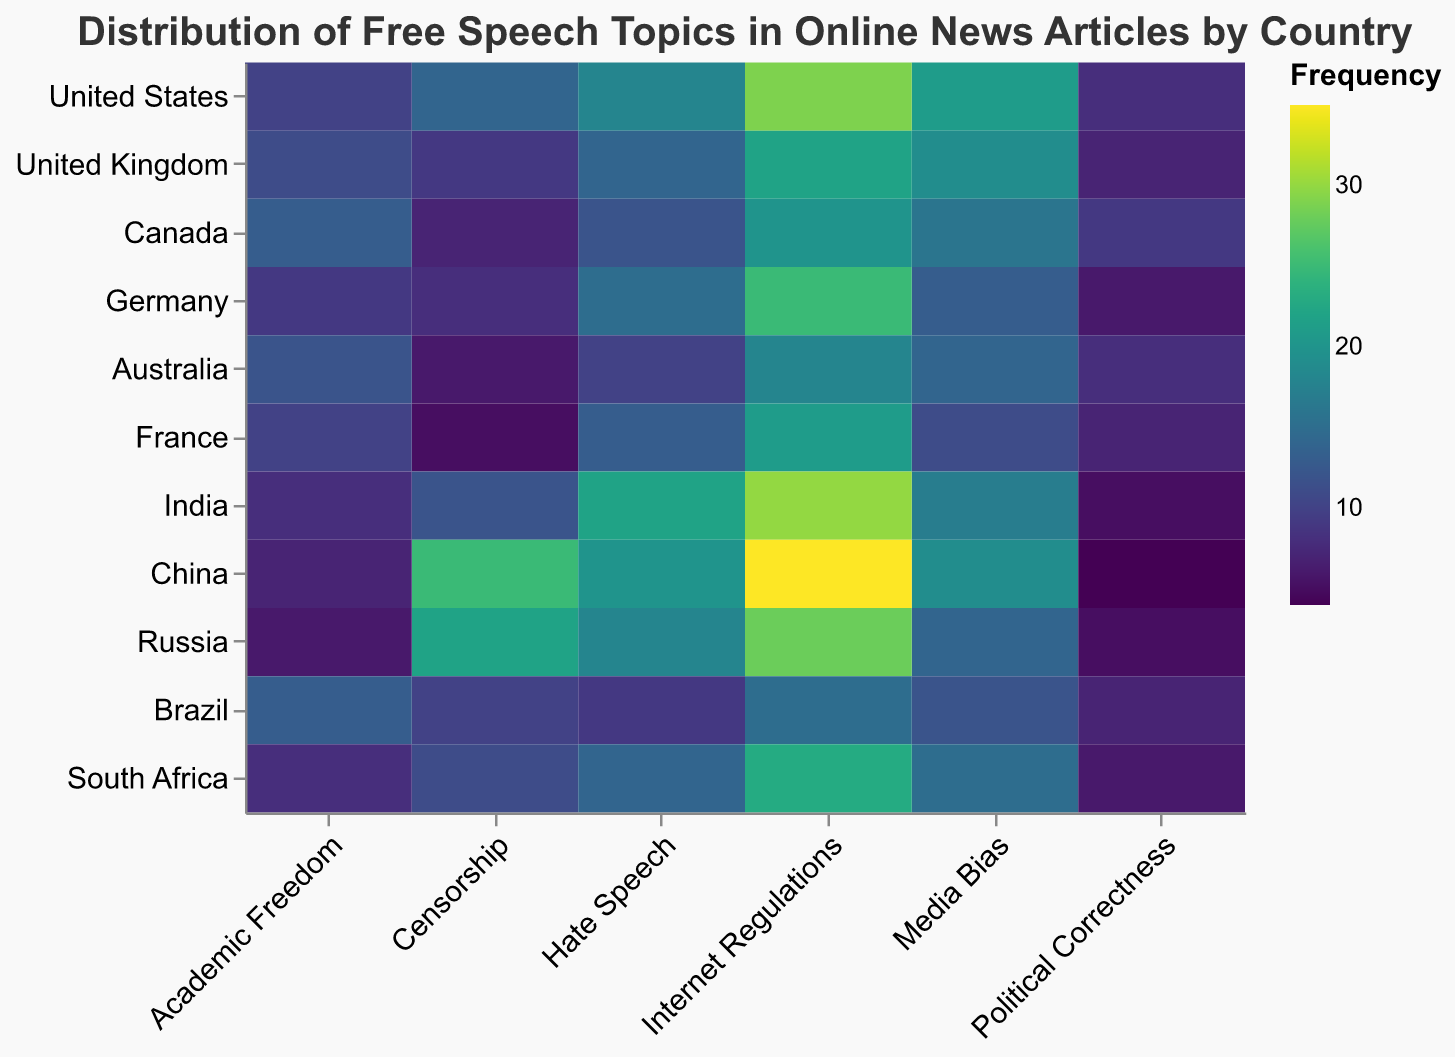What's the title of the heatmap? The title of the heatmap is usually positioned at the top of the figure. It summarizes the main topic of the heatmap.
Answer: "Distribution of Free Speech Topics in Online News Articles by Country" Which topic is most frequently mentioned in online news articles related to free speech in China? Look at the row for China and find the cell with the highest value.
Answer: Internet Regulations Which country has the lowest frequency of articles discussing Political Correctness? Find the values for "Political Correctness" across all countries and identify the smallest one.
Answer: China What's the total number of articles related to Censorship in North American countries (United States and Canada)? Add the values for "Censorship" for the United States and Canada (14 + 7).
Answer: 21 How do the frequencies of articles about Hate Speech in Germany and Brazil compare? Compare the values for "Hate Speech" in the rows for Germany and Brazil (Germany: 15, Brazil: 9).
Answer: Germany has a higher frequency What is the most and least frequently discussed topic in India? Identify the topic with the highest and lowest values in the row for India. Most: Internet Regulations (30), Least: Political Correctness (5).
Answer: Most: Internet Regulations, Least: Political Correctness What is the difference in the frequency of Hate Speech articles between the United States and Russia? Subtract the value of Hate Speech for Russia from the value for the United States (18 - 18).
Answer: 0 Which country mentioned Media Bias more frequently, the United Kingdom or Australia? Compare the values for "Media Bias" in the rows for the United Kingdom and Australia (United Kingdom: 19, Australia: 14).
Answer: United Kingdom What's the sum of articles related to Academic Freedom in the top three countries with the highest Internet Regulations frequency? Identify the top three countries with the highest values for Internet Regulations (China: 35, India: 30, Germany: 25). Then sum their values for Academic Freedom (China: 7, India: 8, Germany: 9).
Answer: 24 